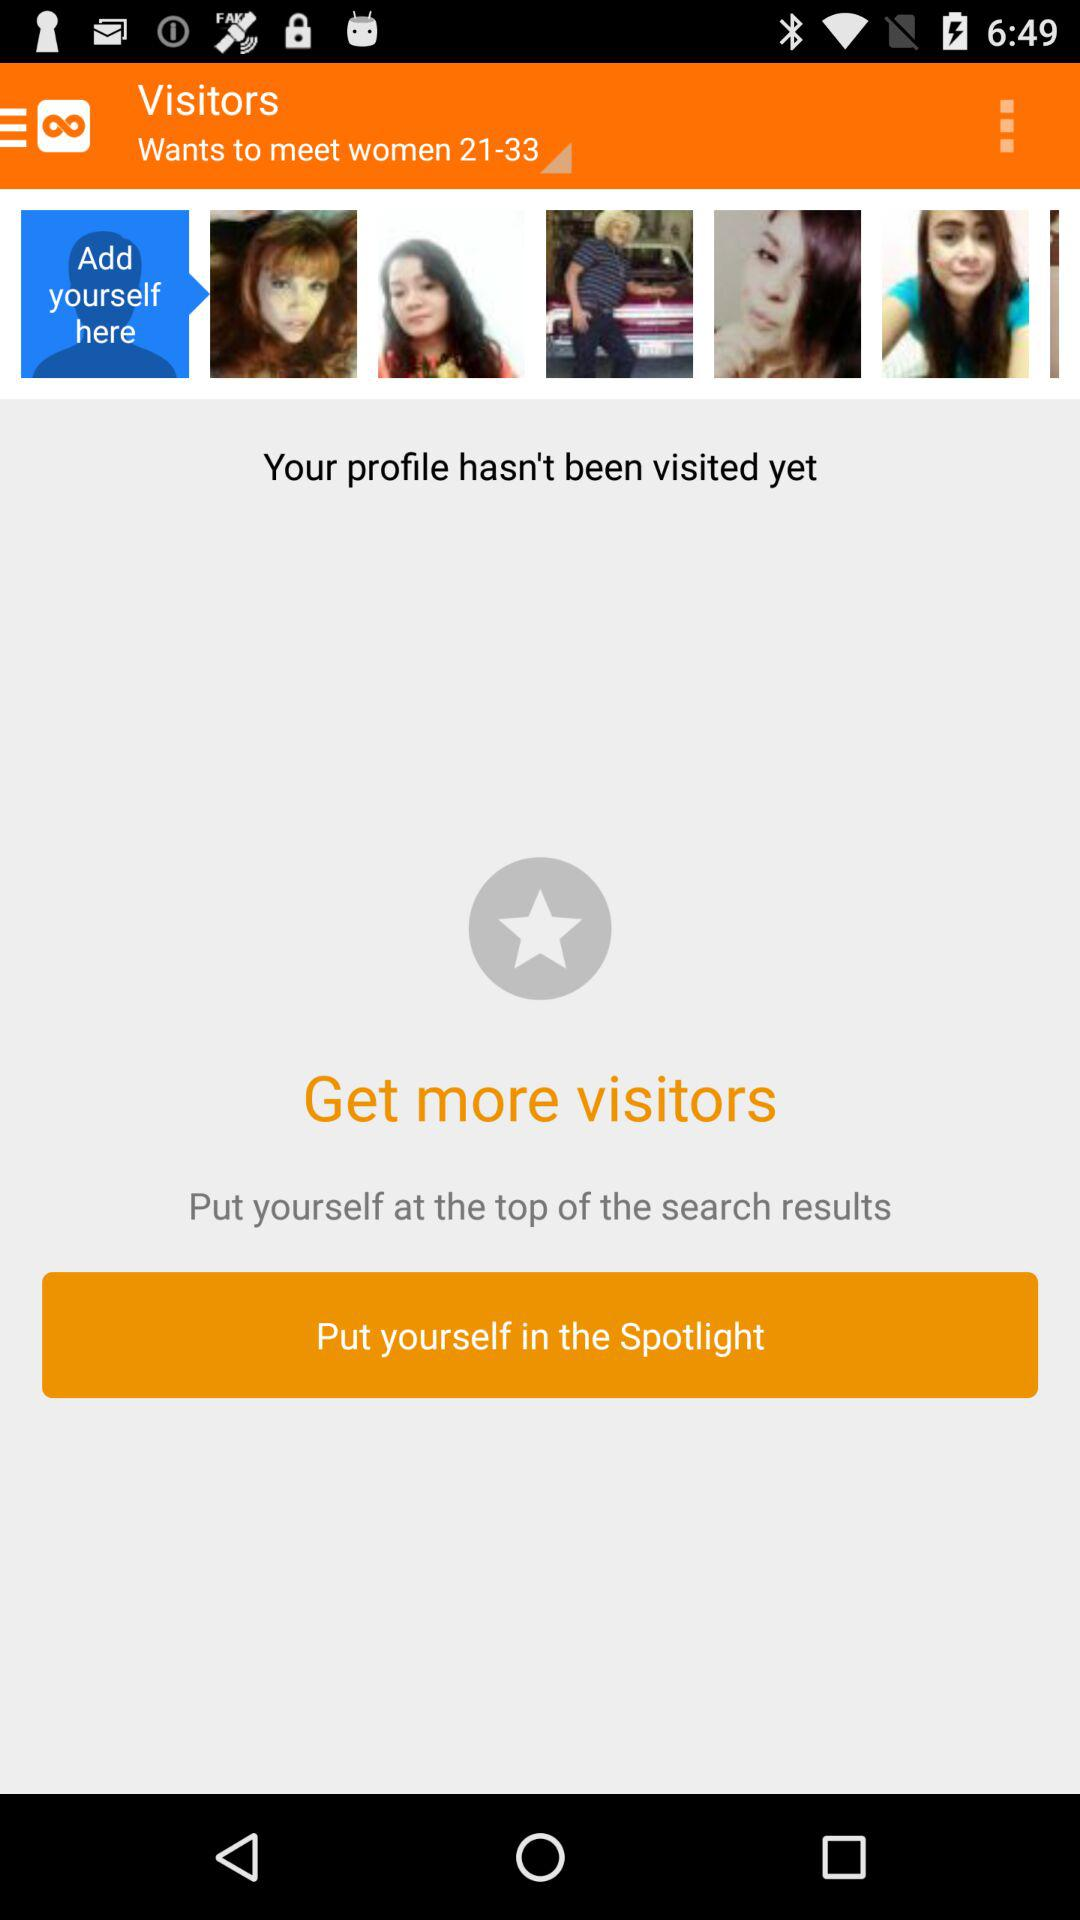How many profile pictures are there?
Answer the question using a single word or phrase. 5 